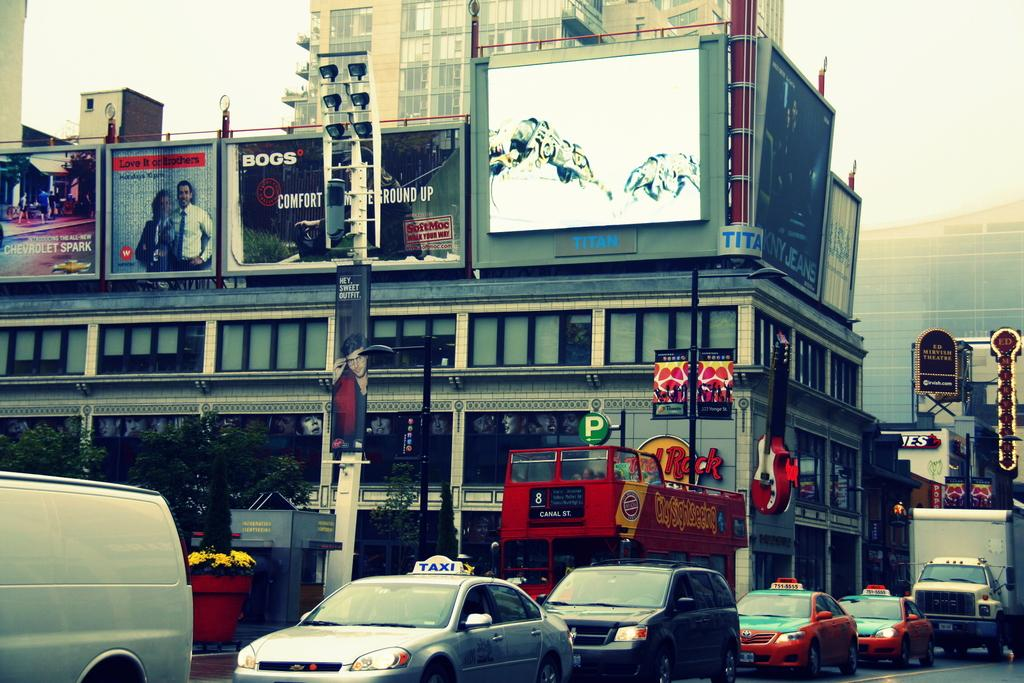<image>
Create a compact narrative representing the image presented. A town or city scene which includes a poster reading comfort. 